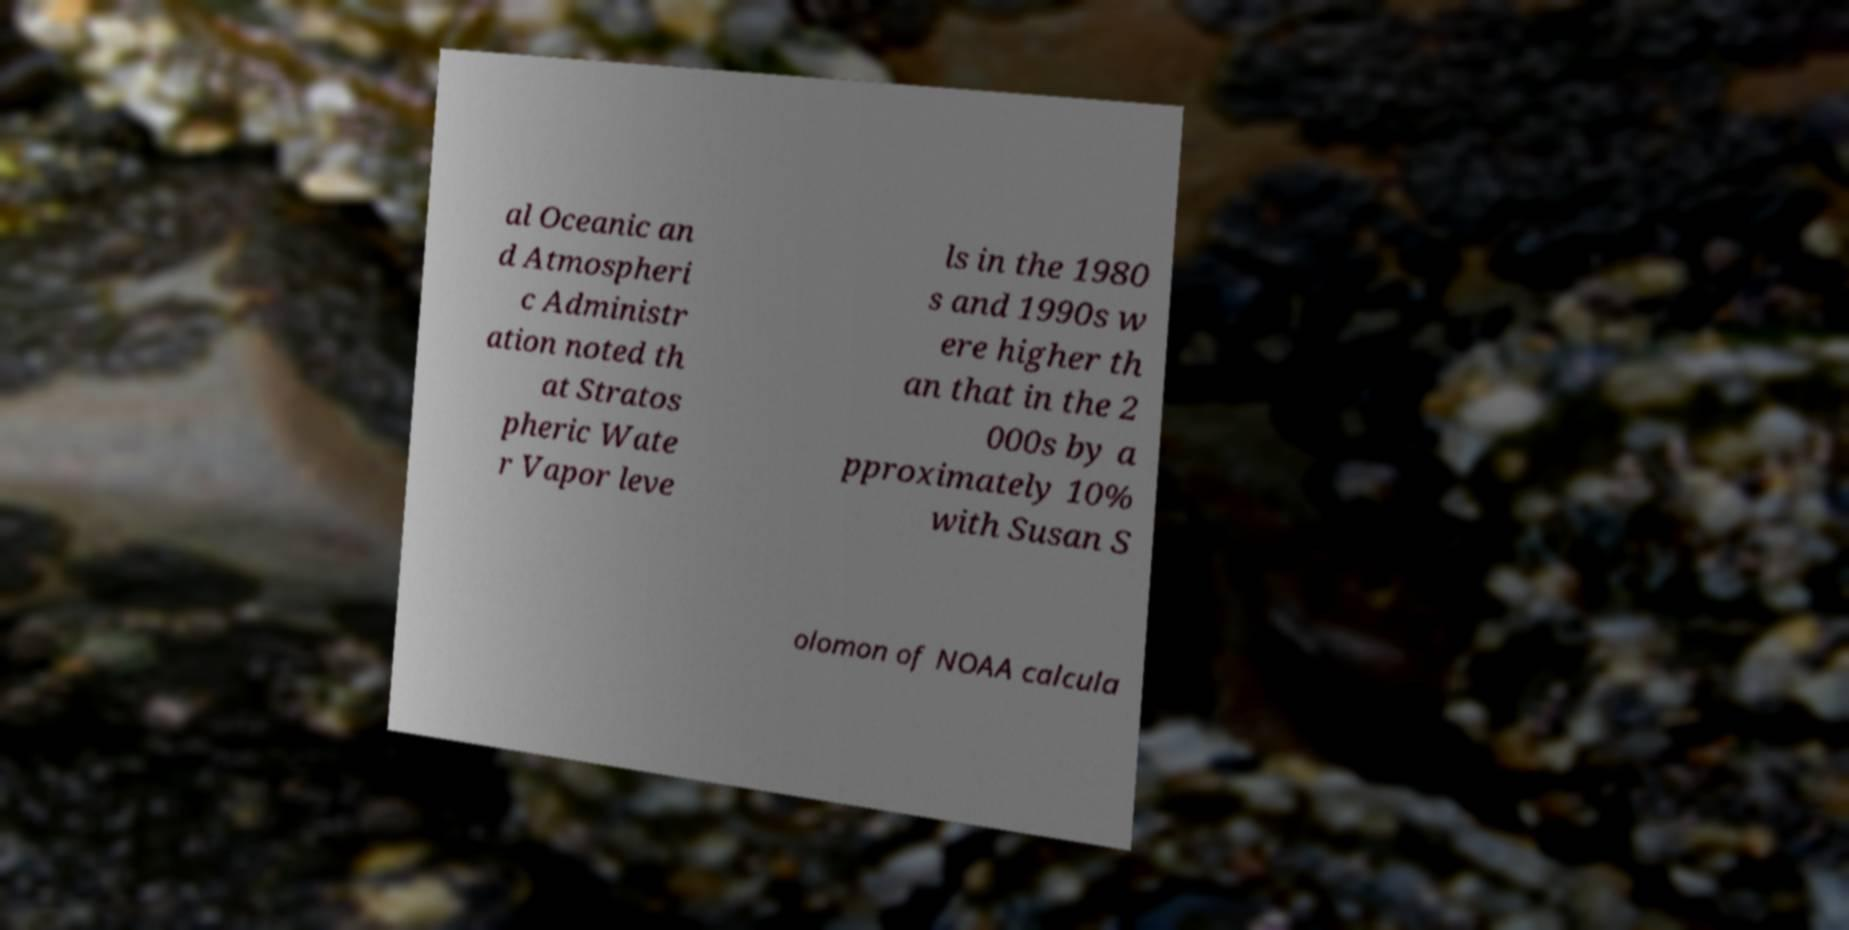Could you assist in decoding the text presented in this image and type it out clearly? al Oceanic an d Atmospheri c Administr ation noted th at Stratos pheric Wate r Vapor leve ls in the 1980 s and 1990s w ere higher th an that in the 2 000s by a pproximately 10% with Susan S olomon of NOAA calcula 